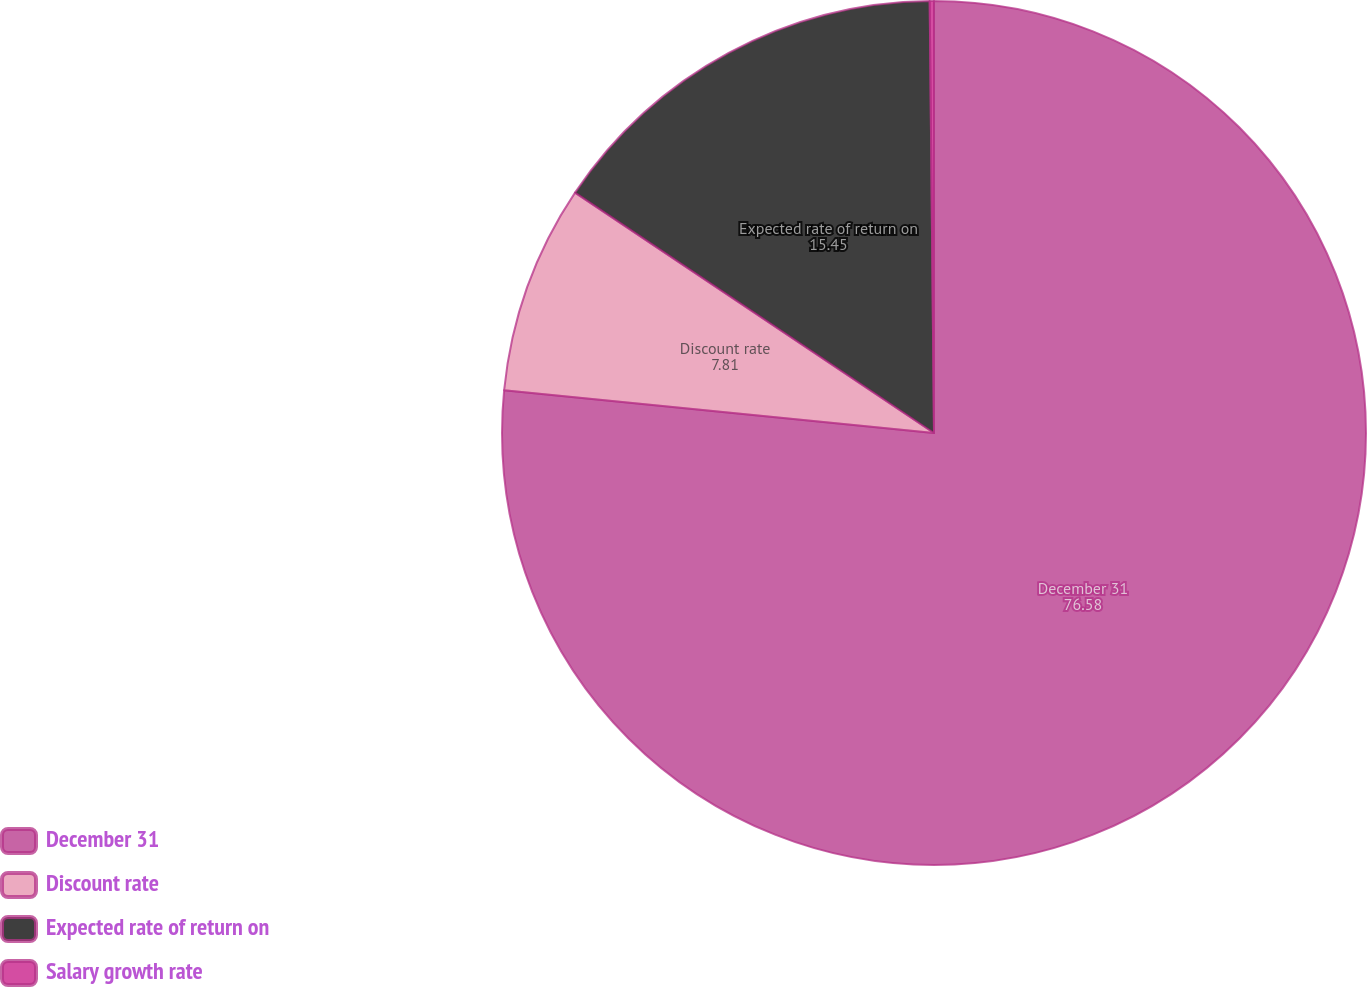Convert chart. <chart><loc_0><loc_0><loc_500><loc_500><pie_chart><fcel>December 31<fcel>Discount rate<fcel>Expected rate of return on<fcel>Salary growth rate<nl><fcel>76.58%<fcel>7.81%<fcel>15.45%<fcel>0.16%<nl></chart> 